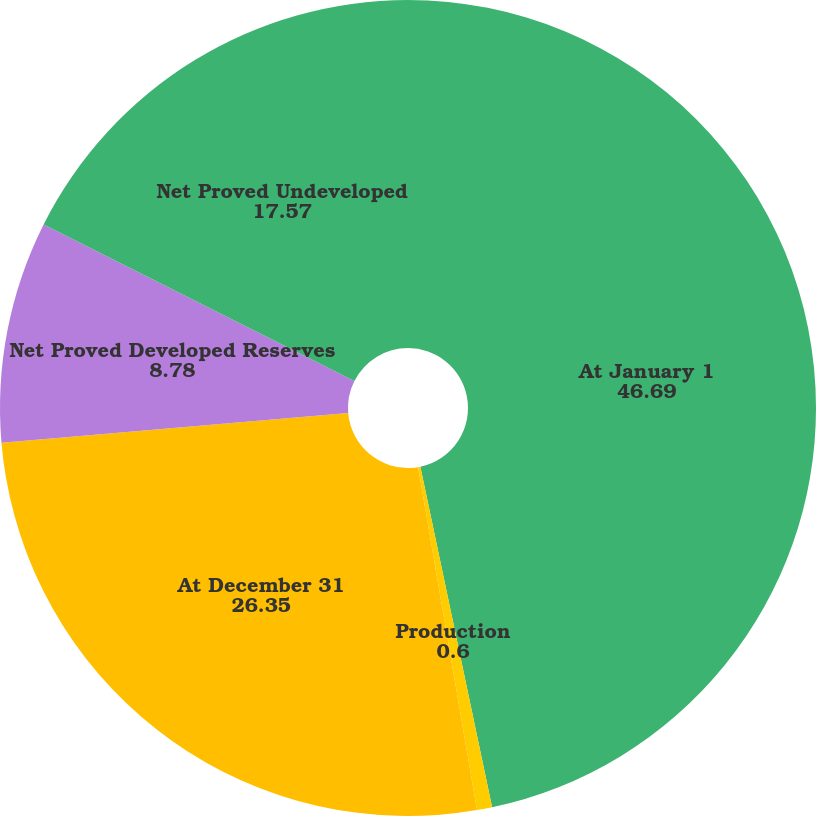Convert chart. <chart><loc_0><loc_0><loc_500><loc_500><pie_chart><fcel>At January 1<fcel>Production<fcel>At December 31<fcel>Net Proved Developed Reserves<fcel>Net Proved Undeveloped<nl><fcel>46.69%<fcel>0.6%<fcel>26.35%<fcel>8.78%<fcel>17.57%<nl></chart> 